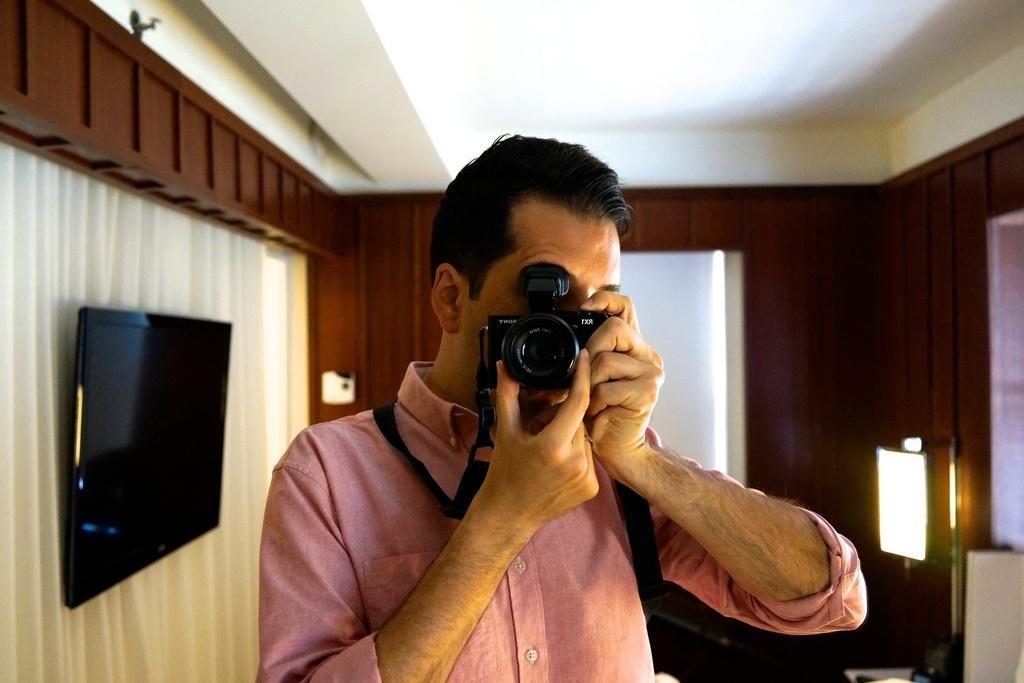Could you give a brief overview of what you see in this image? In this picture a man is holding camera with his both hands. In the back drop there is a television, there is a curtain and there is a lamp. 